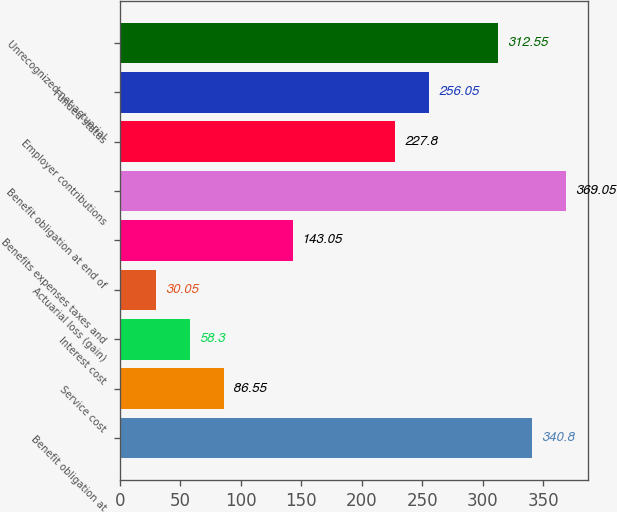Convert chart to OTSL. <chart><loc_0><loc_0><loc_500><loc_500><bar_chart><fcel>Benefit obligation at<fcel>Service cost<fcel>Interest cost<fcel>Actuarial loss (gain)<fcel>Benefits expenses taxes and<fcel>Benefit obligation at end of<fcel>Employer contributions<fcel>Funded status<fcel>Unrecognized net actuarial<nl><fcel>340.8<fcel>86.55<fcel>58.3<fcel>30.05<fcel>143.05<fcel>369.05<fcel>227.8<fcel>256.05<fcel>312.55<nl></chart> 